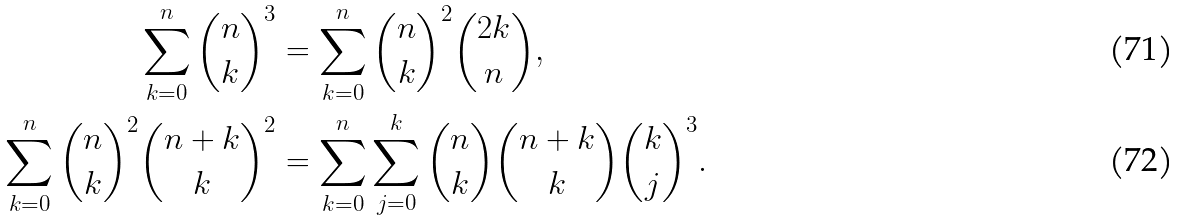<formula> <loc_0><loc_0><loc_500><loc_500>\sum _ { k = 0 } ^ { n } { n \choose k } ^ { 3 } & = \sum _ { k = 0 } ^ { n } { n \choose k } ^ { 2 } { 2 k \choose n } , \\ \sum _ { k = 0 } ^ { n } { n \choose k } ^ { 2 } { n + k \choose k } ^ { 2 } & = \sum _ { k = 0 } ^ { n } \sum _ { j = 0 } ^ { k } { n \choose k } { n + k \choose k } { k \choose j } ^ { 3 } .</formula> 